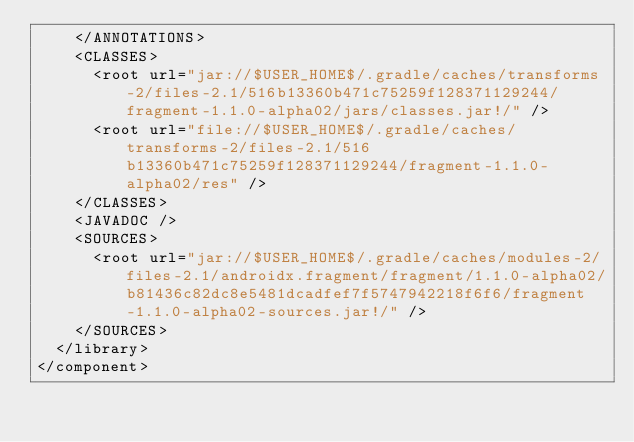<code> <loc_0><loc_0><loc_500><loc_500><_XML_>    </ANNOTATIONS>
    <CLASSES>
      <root url="jar://$USER_HOME$/.gradle/caches/transforms-2/files-2.1/516b13360b471c75259f128371129244/fragment-1.1.0-alpha02/jars/classes.jar!/" />
      <root url="file://$USER_HOME$/.gradle/caches/transforms-2/files-2.1/516b13360b471c75259f128371129244/fragment-1.1.0-alpha02/res" />
    </CLASSES>
    <JAVADOC />
    <SOURCES>
      <root url="jar://$USER_HOME$/.gradle/caches/modules-2/files-2.1/androidx.fragment/fragment/1.1.0-alpha02/b81436c82dc8e5481dcadfef7f5747942218f6f6/fragment-1.1.0-alpha02-sources.jar!/" />
    </SOURCES>
  </library>
</component></code> 